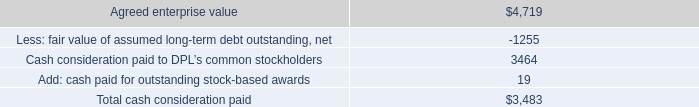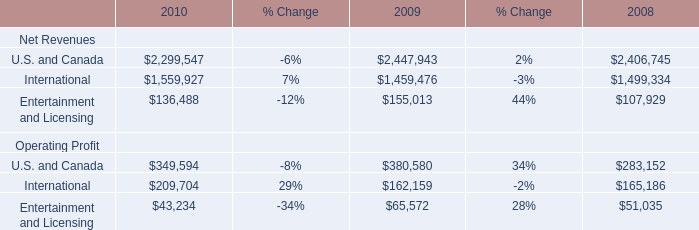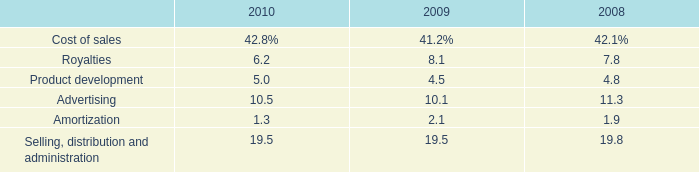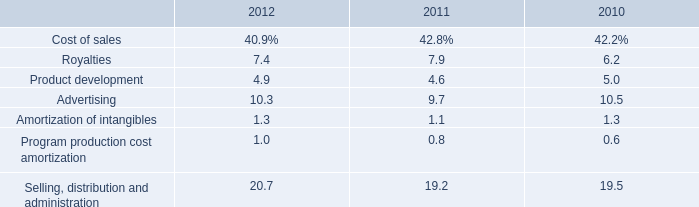What is the growth rate of Net Revenues for Entertainment and Licensing between 2009 and 2010? 
Computations: ((136488 - 155013) / 155013)
Answer: -0.11951. 